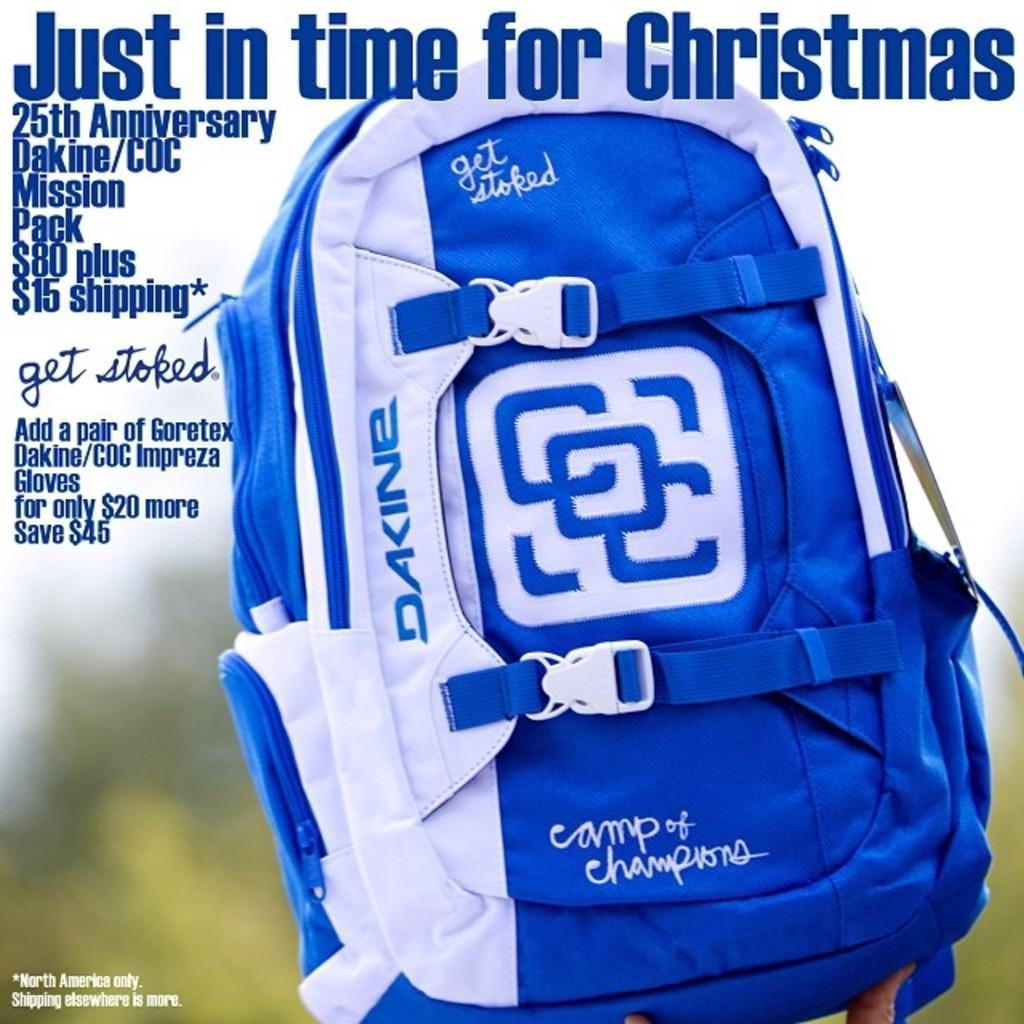<image>
Summarize the visual content of the image. A magazine cover that says Just in time for Christmas. 